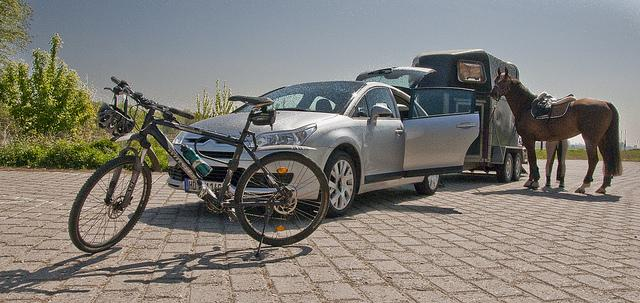What is being used to pull the black trailer? Please explain your reasoning. car. The car is pulling the trailer. 